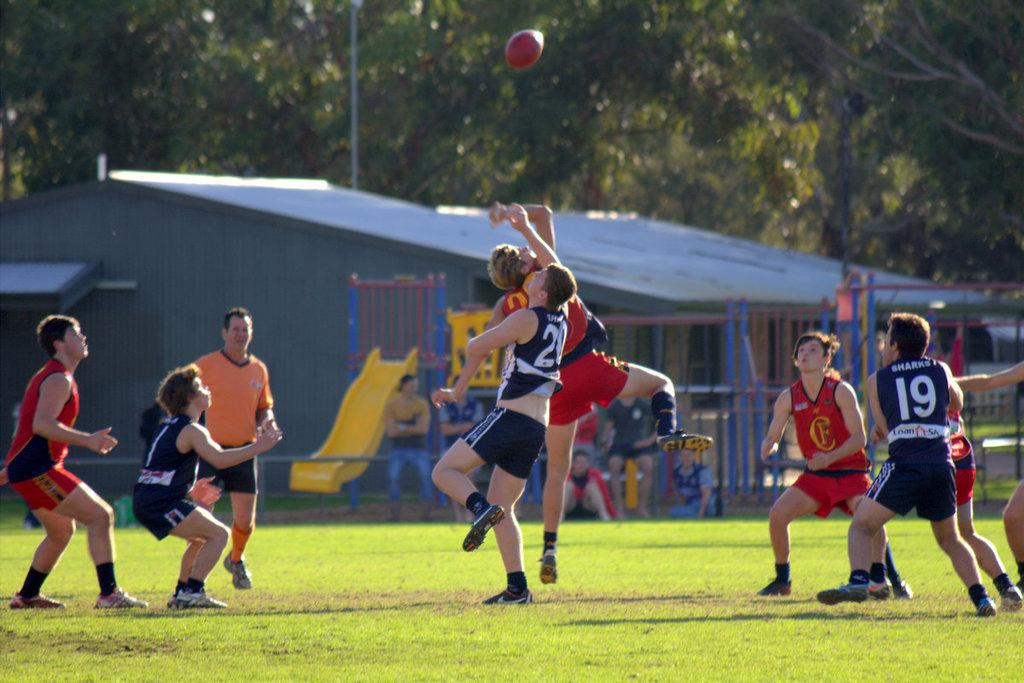What is in the air in the image? There is a ball in the air in the image. Where are the people located in the image? The people are on the grass in the image. What are the people doing in the image? The people are sliding in the image. What type of structure can be seen in the image? There is a shed in the image. What architectural feature is present in the image? There is a fence in the image. What can be found in the image besides the people and the shed? There are objects in the image. What is visible in the background of the image? There are trees visible in the background of the image. What type of cake is being served at the event in the image? There is no event or cake present in the image. Can you provide an example of a person sliding in the image? There is no need to provide an example, as the people sliding are already visible in the image. 